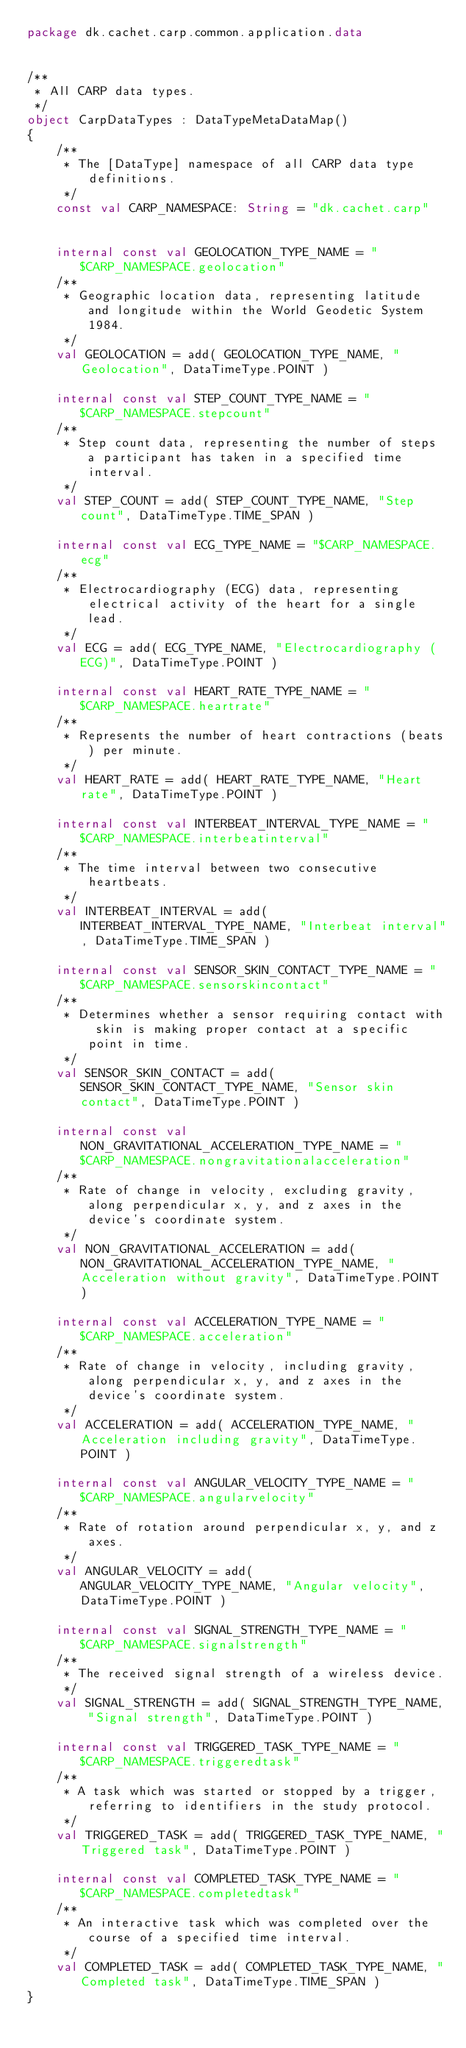<code> <loc_0><loc_0><loc_500><loc_500><_Kotlin_>package dk.cachet.carp.common.application.data


/**
 * All CARP data types.
 */
object CarpDataTypes : DataTypeMetaDataMap()
{
    /**
     * The [DataType] namespace of all CARP data type definitions.
     */
    const val CARP_NAMESPACE: String = "dk.cachet.carp"


    internal const val GEOLOCATION_TYPE_NAME = "$CARP_NAMESPACE.geolocation"
    /**
     * Geographic location data, representing latitude and longitude within the World Geodetic System 1984.
     */
    val GEOLOCATION = add( GEOLOCATION_TYPE_NAME, "Geolocation", DataTimeType.POINT )

    internal const val STEP_COUNT_TYPE_NAME = "$CARP_NAMESPACE.stepcount"
    /**
     * Step count data, representing the number of steps a participant has taken in a specified time interval.
     */
    val STEP_COUNT = add( STEP_COUNT_TYPE_NAME, "Step count", DataTimeType.TIME_SPAN )

    internal const val ECG_TYPE_NAME = "$CARP_NAMESPACE.ecg"
    /**
     * Electrocardiography (ECG) data, representing electrical activity of the heart for a single lead.
     */
    val ECG = add( ECG_TYPE_NAME, "Electrocardiography (ECG)", DataTimeType.POINT )

    internal const val HEART_RATE_TYPE_NAME = "$CARP_NAMESPACE.heartrate"
    /**
     * Represents the number of heart contractions (beats) per minute.
     */
    val HEART_RATE = add( HEART_RATE_TYPE_NAME, "Heart rate", DataTimeType.POINT )

    internal const val INTERBEAT_INTERVAL_TYPE_NAME = "$CARP_NAMESPACE.interbeatinterval"
    /**
     * The time interval between two consecutive heartbeats.
     */
    val INTERBEAT_INTERVAL = add( INTERBEAT_INTERVAL_TYPE_NAME, "Interbeat interval", DataTimeType.TIME_SPAN )

    internal const val SENSOR_SKIN_CONTACT_TYPE_NAME = "$CARP_NAMESPACE.sensorskincontact"
    /**
     * Determines whether a sensor requiring contact with skin is making proper contact at a specific point in time.
     */
    val SENSOR_SKIN_CONTACT = add( SENSOR_SKIN_CONTACT_TYPE_NAME, "Sensor skin contact", DataTimeType.POINT )

    internal const val NON_GRAVITATIONAL_ACCELERATION_TYPE_NAME = "$CARP_NAMESPACE.nongravitationalacceleration"
    /**
     * Rate of change in velocity, excluding gravity, along perpendicular x, y, and z axes in the device's coordinate system.
     */
    val NON_GRAVITATIONAL_ACCELERATION = add( NON_GRAVITATIONAL_ACCELERATION_TYPE_NAME, "Acceleration without gravity", DataTimeType.POINT )

    internal const val ACCELERATION_TYPE_NAME = "$CARP_NAMESPACE.acceleration"
    /**
     * Rate of change in velocity, including gravity, along perpendicular x, y, and z axes in the device's coordinate system.
     */
    val ACCELERATION = add( ACCELERATION_TYPE_NAME, "Acceleration including gravity", DataTimeType.POINT )

    internal const val ANGULAR_VELOCITY_TYPE_NAME = "$CARP_NAMESPACE.angularvelocity"
    /**
     * Rate of rotation around perpendicular x, y, and z axes.
     */
    val ANGULAR_VELOCITY = add( ANGULAR_VELOCITY_TYPE_NAME, "Angular velocity", DataTimeType.POINT )

    internal const val SIGNAL_STRENGTH_TYPE_NAME = "$CARP_NAMESPACE.signalstrength"
    /**
     * The received signal strength of a wireless device.
     */
    val SIGNAL_STRENGTH = add( SIGNAL_STRENGTH_TYPE_NAME, "Signal strength", DataTimeType.POINT )

    internal const val TRIGGERED_TASK_TYPE_NAME = "$CARP_NAMESPACE.triggeredtask"
    /**
     * A task which was started or stopped by a trigger, referring to identifiers in the study protocol.
     */
    val TRIGGERED_TASK = add( TRIGGERED_TASK_TYPE_NAME, "Triggered task", DataTimeType.POINT )

    internal const val COMPLETED_TASK_TYPE_NAME = "$CARP_NAMESPACE.completedtask"
    /**
     * An interactive task which was completed over the course of a specified time interval.
     */
    val COMPLETED_TASK = add( COMPLETED_TASK_TYPE_NAME, "Completed task", DataTimeType.TIME_SPAN )
}
</code> 